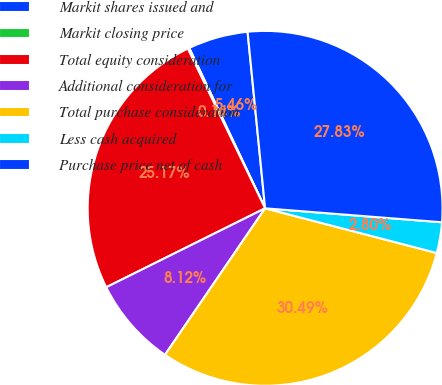Convert chart. <chart><loc_0><loc_0><loc_500><loc_500><pie_chart><fcel>Markit shares issued and<fcel>Markit closing price<fcel>Total equity consideration<fcel>Additional consideration for<fcel>Total purchase consideration<fcel>Less cash acquired<fcel>Purchase price net of cash<nl><fcel>5.46%<fcel>0.14%<fcel>25.17%<fcel>8.12%<fcel>30.49%<fcel>2.8%<fcel>27.83%<nl></chart> 